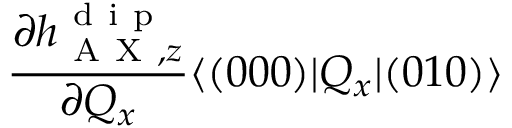<formula> <loc_0><loc_0><loc_500><loc_500>\frac { \partial h _ { A X , z } ^ { d i p } } { \partial Q _ { x } } \langle ( 0 0 0 ) | Q _ { x } | ( 0 1 0 ) \rangle</formula> 